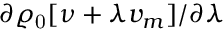Convert formula to latex. <formula><loc_0><loc_0><loc_500><loc_500>\partial \varrho _ { 0 } [ \nu + \lambda v _ { m } ] / \partial \lambda</formula> 